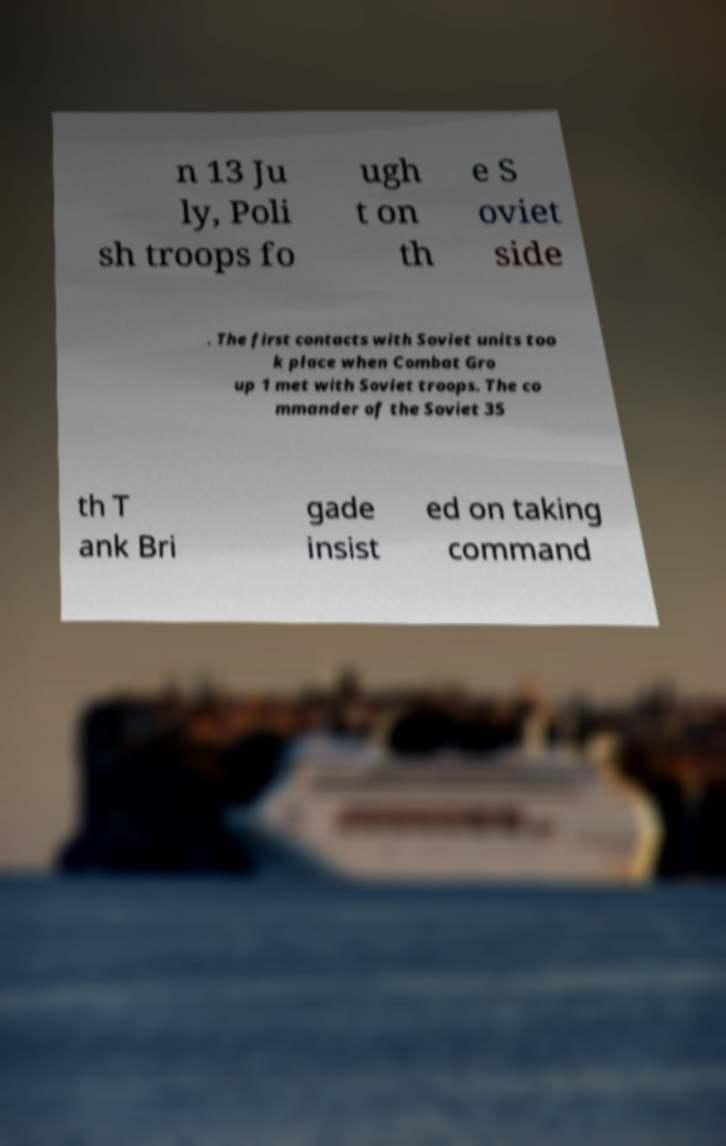What messages or text are displayed in this image? I need them in a readable, typed format. n 13 Ju ly, Poli sh troops fo ugh t on th e S oviet side . The first contacts with Soviet units too k place when Combat Gro up 1 met with Soviet troops. The co mmander of the Soviet 35 th T ank Bri gade insist ed on taking command 